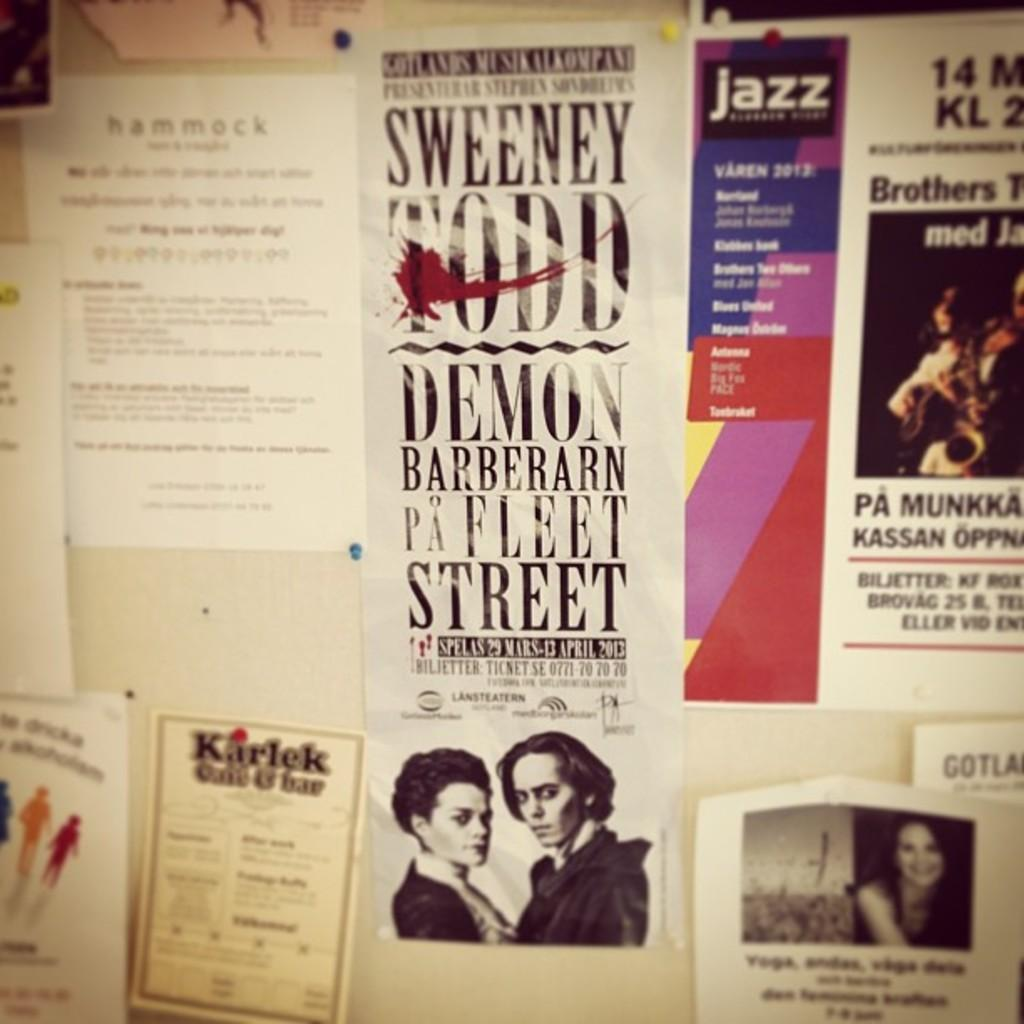<image>
Summarize the visual content of the image. An ad is pinned up for the musical Sweeney Todd. 